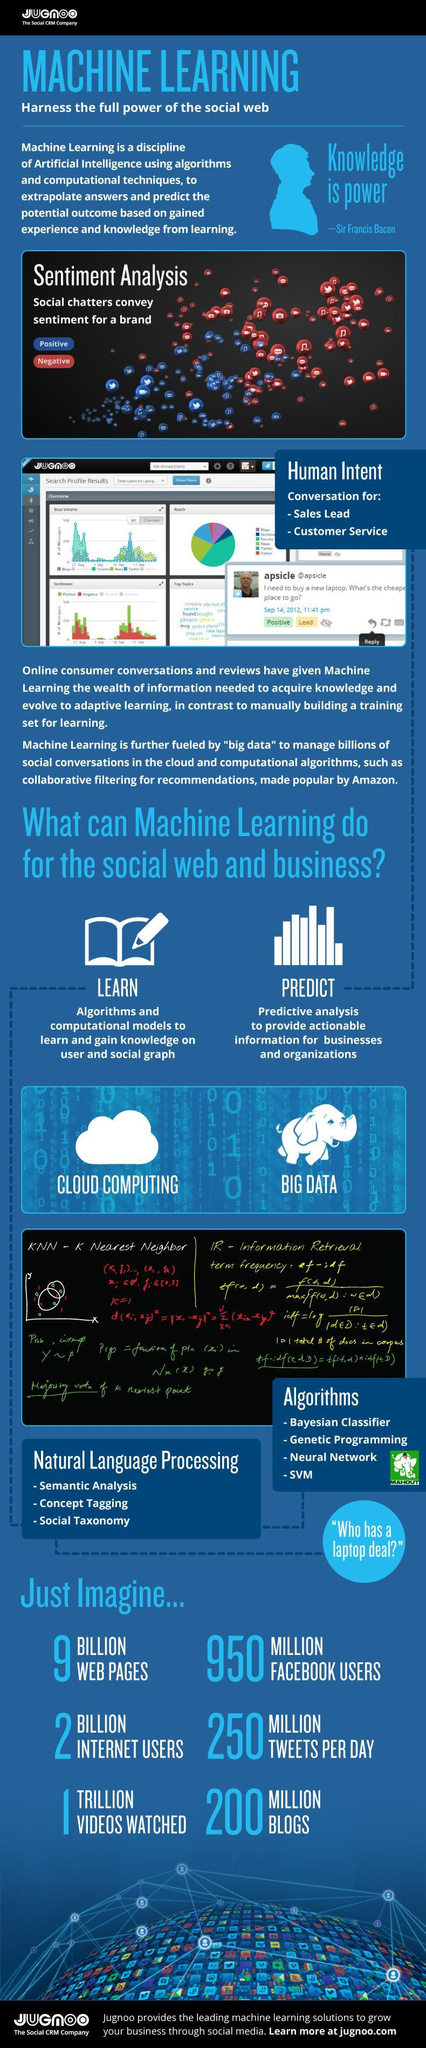How many Natural Language Processing types are listed?
Answer the question with a short phrase. 3 How many Algorithms are listed? 4 Which is the animal shown near the text "Big data"- horse, lion, elephant, tiger? elephant Close to which day Positive Sentiments reached the highest value? 17  Sep 